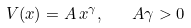<formula> <loc_0><loc_0><loc_500><loc_500>V ( x ) = A \, x ^ { \gamma } , \quad A \gamma > 0</formula> 